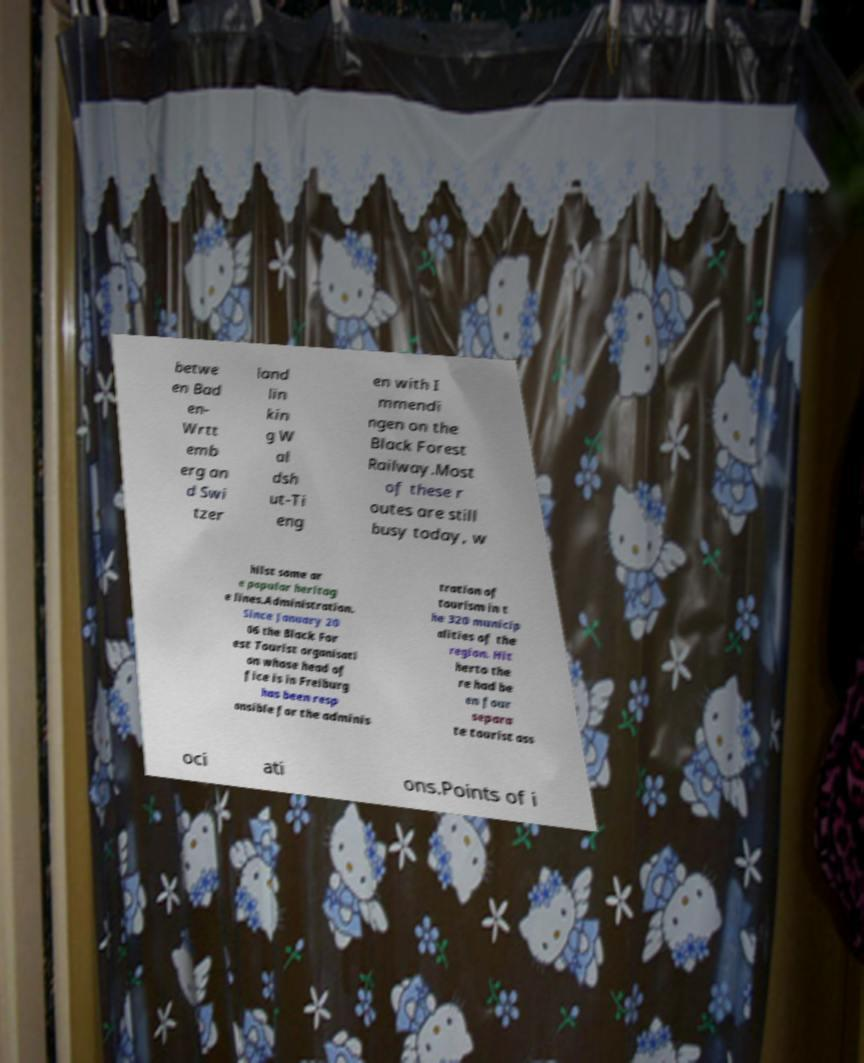There's text embedded in this image that I need extracted. Can you transcribe it verbatim? betwe en Bad en- Wrtt emb erg an d Swi tzer land lin kin g W al dsh ut-Ti eng en with I mmendi ngen on the Black Forest Railway.Most of these r outes are still busy today, w hilst some ar e popular heritag e lines.Administration. Since January 20 06 the Black For est Tourist organisati on whose head of fice is in Freiburg has been resp onsible for the adminis tration of tourism in t he 320 municip alities of the region. Hit herto the re had be en four separa te tourist ass oci ati ons.Points of i 